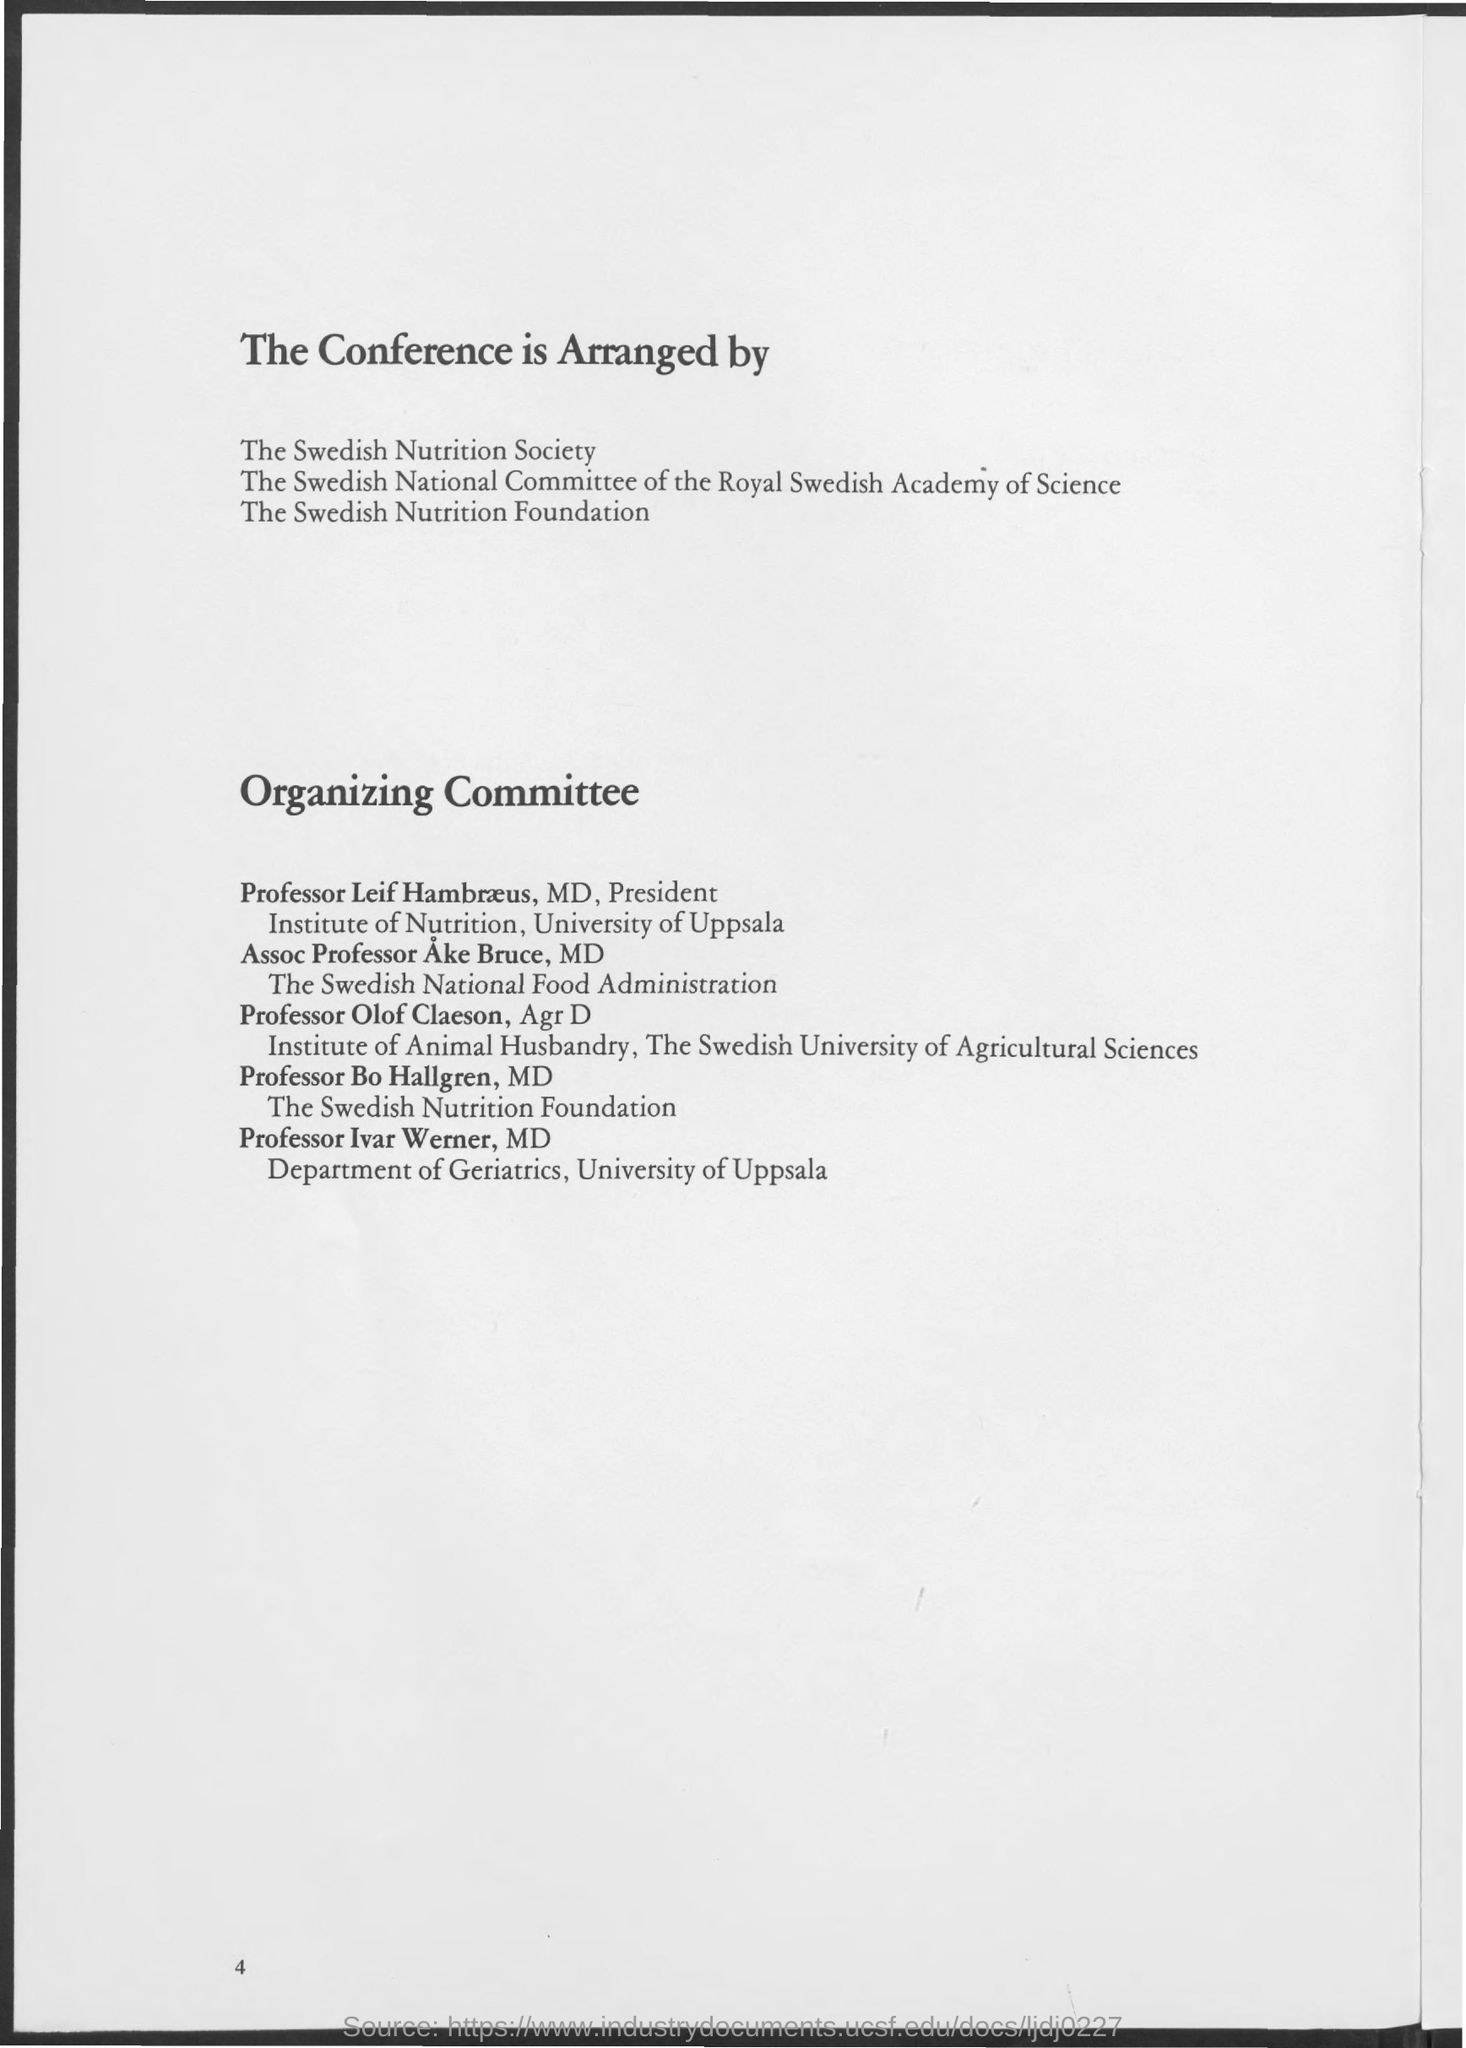What is the page number at bottom of page?
Offer a very short reply. 4. Who is representing department of geriatrics, university of uppsala?
Your response must be concise. Professor Ivar Werner. Who is representing the swedish national food administration?
Your answer should be very brief. Assoc Professor Ake Bruce, MD. 